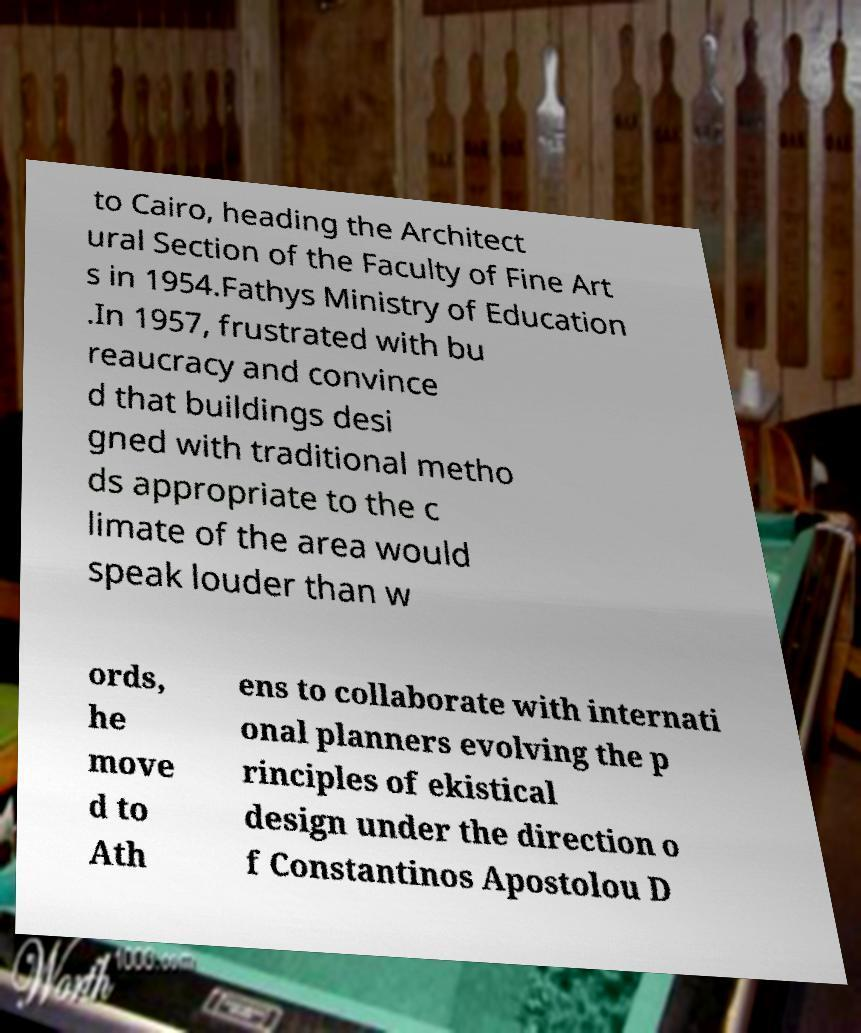For documentation purposes, I need the text within this image transcribed. Could you provide that? to Cairo, heading the Architect ural Section of the Faculty of Fine Art s in 1954.Fathys Ministry of Education .In 1957, frustrated with bu reaucracy and convince d that buildings desi gned with traditional metho ds appropriate to the c limate of the area would speak louder than w ords, he move d to Ath ens to collaborate with internati onal planners evolving the p rinciples of ekistical design under the direction o f Constantinos Apostolou D 